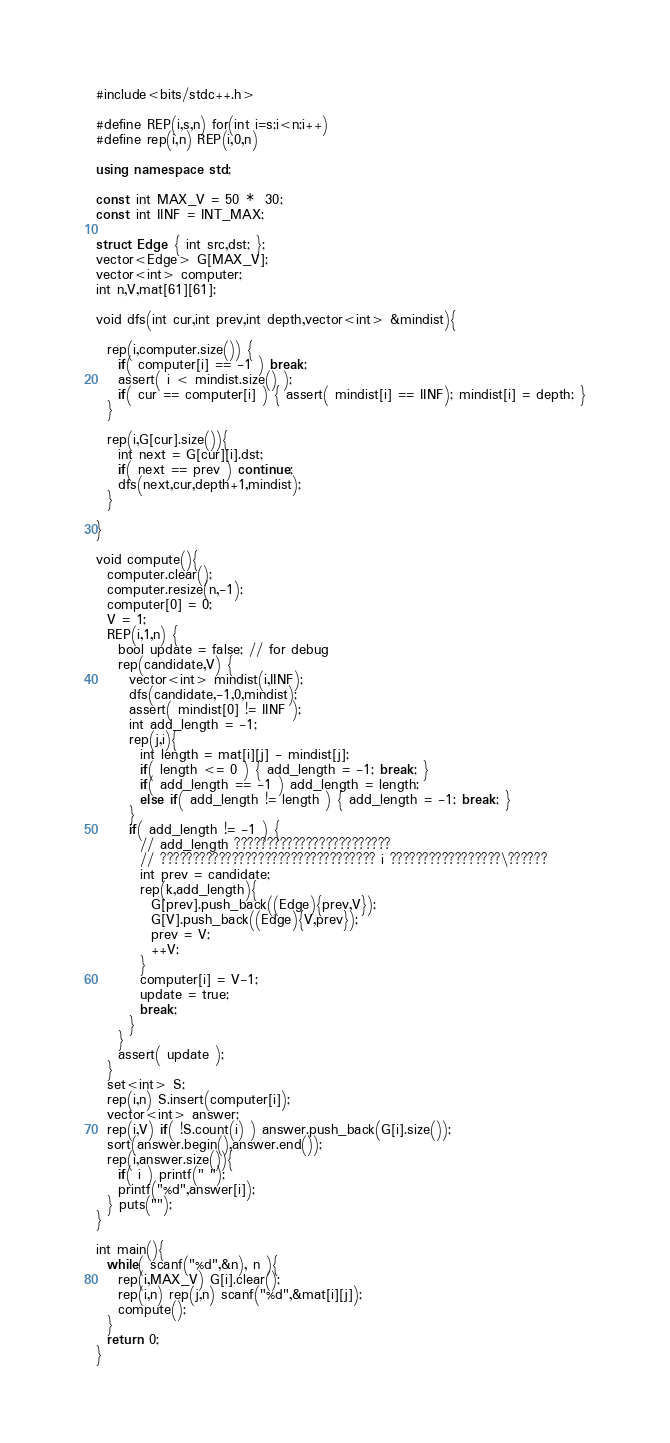<code> <loc_0><loc_0><loc_500><loc_500><_C++_>#include<bits/stdc++.h>

#define REP(i,s,n) for(int i=s;i<n;i++)
#define rep(i,n) REP(i,0,n)

using namespace std;

const int MAX_V = 50 *  30;
const int IINF = INT_MAX;

struct Edge { int src,dst; };
vector<Edge> G[MAX_V];
vector<int> computer;
int n,V,mat[61][61];

void dfs(int cur,int prev,int depth,vector<int> &mindist){

  rep(i,computer.size()) {
    if( computer[i] == -1 ) break;
    assert( i < mindist.size() );
    if( cur == computer[i] ) { assert( mindist[i] == IINF); mindist[i] = depth; }
  }

  rep(i,G[cur].size()){
    int next = G[cur][i].dst;
    if( next == prev ) continue;
    dfs(next,cur,depth+1,mindist);
  }

}

void compute(){
  computer.clear();
  computer.resize(n,-1);
  computer[0] = 0;
  V = 1;
  REP(i,1,n) {
    bool update = false; // for debug
    rep(candidate,V) {
      vector<int> mindist(i,IINF);
      dfs(candidate,-1,0,mindist);
      assert( mindist[0] != IINF );
      int add_length = -1;
      rep(j,i){
        int length = mat[i][j] - mindist[j];
        if( length <= 0 ) { add_length = -1; break; }
        if( add_length == -1 ) add_length = length;
        else if( add_length != length ) { add_length = -1; break; }
      }
      if( add_length != -1 ) {
        // add_length ????????????????????????
        // ????????????????????????????????? i ?????????????????\??????
        int prev = candidate;
        rep(k,add_length){
          G[prev].push_back((Edge){prev,V});
          G[V].push_back((Edge){V,prev});
          prev = V;
          ++V;
        }
        computer[i] = V-1;
        update = true;
        break;
      }
    }
    assert( update );
  }
  set<int> S;
  rep(i,n) S.insert(computer[i]);
  vector<int> answer;
  rep(i,V) if( !S.count(i) ) answer.push_back(G[i].size());
  sort(answer.begin(),answer.end());
  rep(i,answer.size()){
    if( i ) printf(" ");
    printf("%d",answer[i]);
  } puts("");
}

int main(){
  while( scanf("%d",&n), n ){
    rep(i,MAX_V) G[i].clear();
    rep(i,n) rep(j,n) scanf("%d",&mat[i][j]);
    compute();
  }
  return 0;
}</code> 